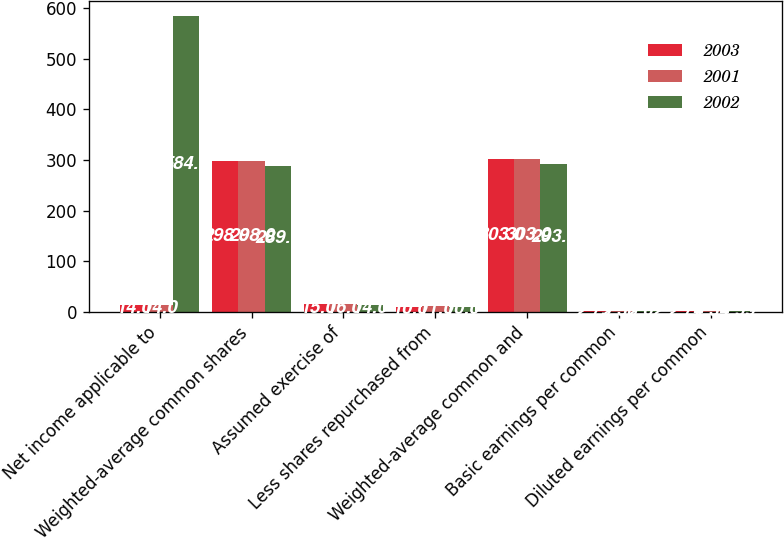Convert chart to OTSL. <chart><loc_0><loc_0><loc_500><loc_500><stacked_bar_chart><ecel><fcel>Net income applicable to<fcel>Weighted-average common shares<fcel>Assumed exercise of<fcel>Less shares repurchased from<fcel>Weighted-average common and<fcel>Basic earnings per common<fcel>Diluted earnings per common<nl><fcel>2003<fcel>14<fcel>298<fcel>15<fcel>10<fcel>303<fcel>2.79<fcel>2.74<nl><fcel>2001<fcel>14<fcel>298<fcel>16<fcel>11<fcel>303<fcel>2.38<fcel>2.34<nl><fcel>2002<fcel>584<fcel>289<fcel>14<fcel>10<fcel>293<fcel>2.02<fcel>1.99<nl></chart> 